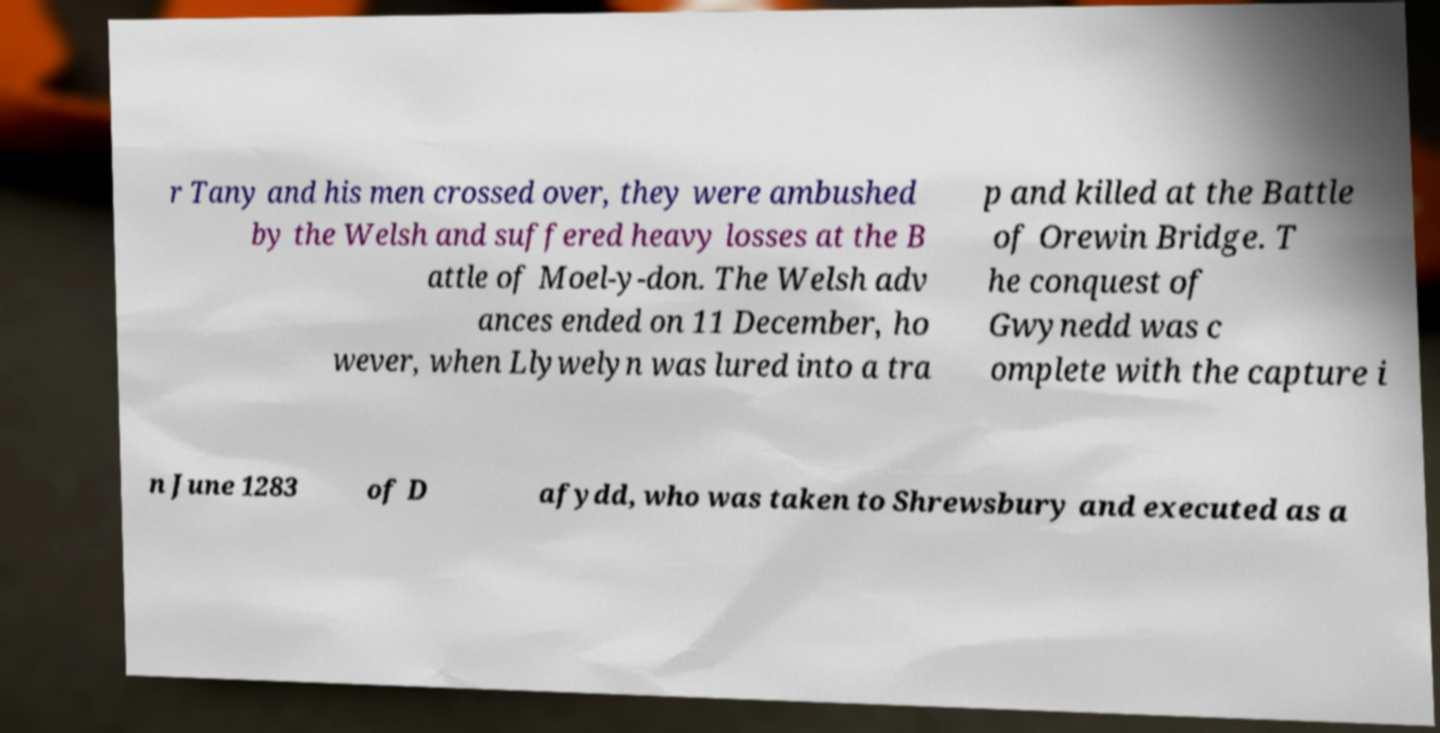For documentation purposes, I need the text within this image transcribed. Could you provide that? r Tany and his men crossed over, they were ambushed by the Welsh and suffered heavy losses at the B attle of Moel-y-don. The Welsh adv ances ended on 11 December, ho wever, when Llywelyn was lured into a tra p and killed at the Battle of Orewin Bridge. T he conquest of Gwynedd was c omplete with the capture i n June 1283 of D afydd, who was taken to Shrewsbury and executed as a 